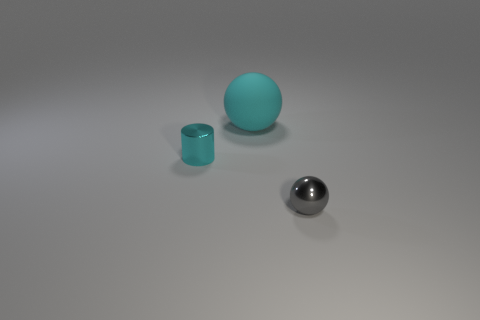There is a small cyan object that is made of the same material as the small ball; what is its shape?
Provide a succinct answer. Cylinder. There is a cyan object in front of the large cyan object; does it have the same shape as the big rubber object?
Give a very brief answer. No. How many objects are either small cyan cylinders or cyan matte objects?
Offer a terse response. 2. What material is the object that is behind the gray shiny ball and on the right side of the cyan shiny cylinder?
Offer a terse response. Rubber. Is the gray shiny thing the same size as the cyan rubber thing?
Give a very brief answer. No. What is the size of the sphere behind the metal object on the right side of the rubber ball?
Keep it short and to the point. Large. What number of objects are both to the left of the large cyan rubber ball and in front of the cyan shiny object?
Offer a very short reply. 0. There is a small metal thing left of the tiny object that is right of the cyan shiny cylinder; are there any matte balls that are behind it?
Your response must be concise. Yes. What is the shape of the cyan metallic thing that is the same size as the gray ball?
Keep it short and to the point. Cylinder. Is there a rubber ball that has the same color as the tiny cylinder?
Your answer should be compact. Yes. 